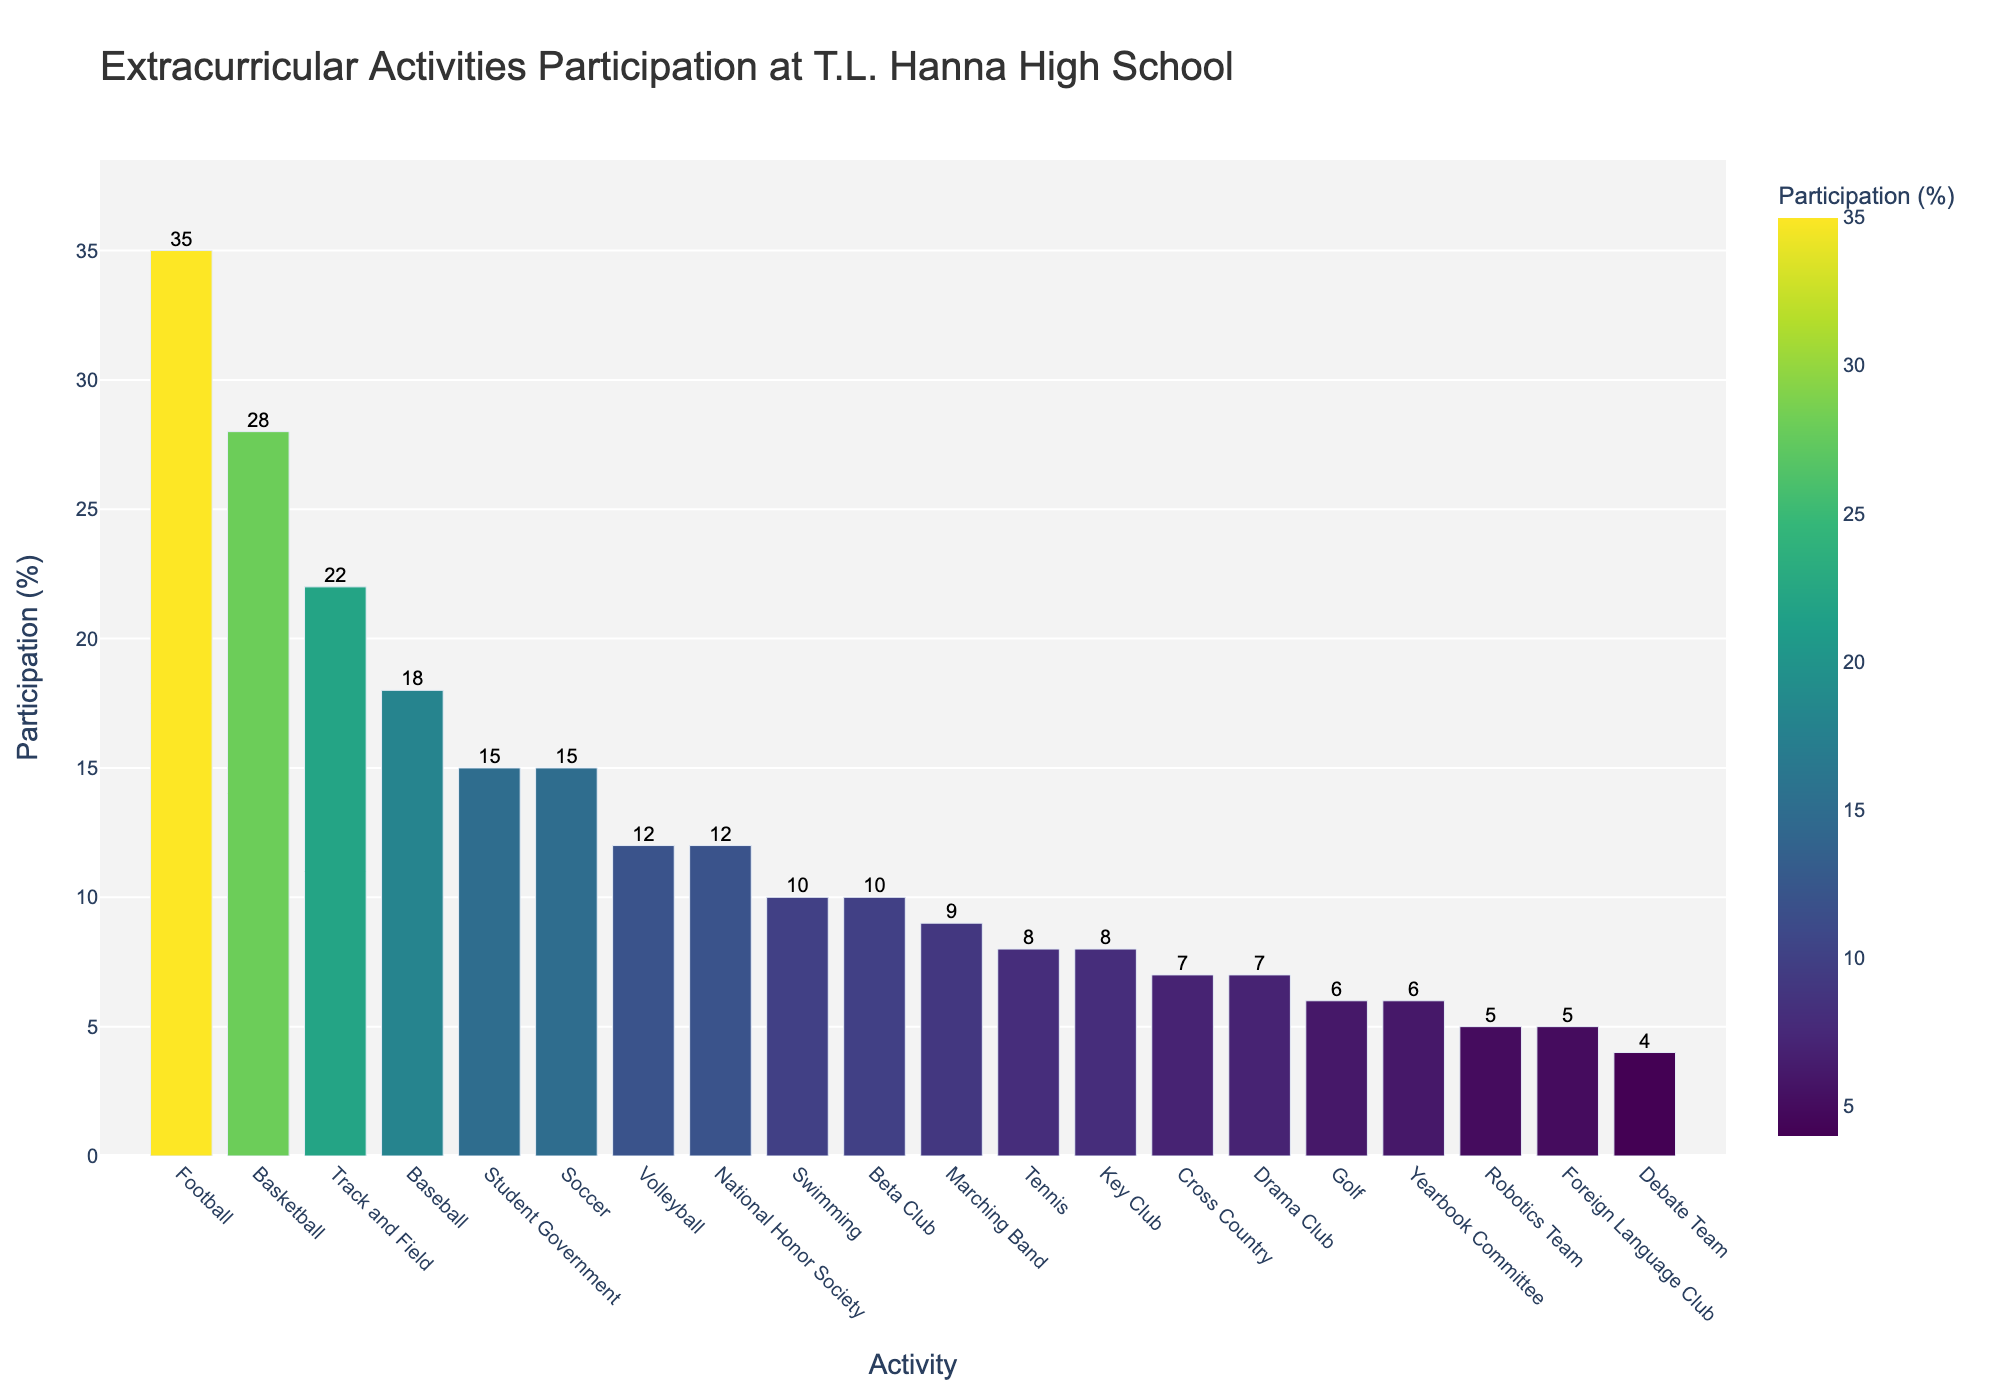Which activity has the highest participation percentage? The bar chart shows the participation percentages for each extracurricular activity. By observing the tallest bar, we see that Football has the highest participation percentage.
Answer: Football What is the difference in participation percentage between Football and Swimming? The bar chart shows that Football has a 35% participation rate, and Swimming has a 10% participation rate. The difference is calculated as 35% - 10%.
Answer: 25% Which two activities have equal participation percentages? By observing the heights of the bars, we see that both Soccer and Student Government have a participation rate of 15%.
Answer: Soccer and Student Government What is the combined participation percentage for Track and Field, and Volleyball? The participation percentages for Track and Field and Volleyball are 22% and 12%, respectively. Adding them together gives 22% + 12%.
Answer: 34% Which activity has the lowest participation percentage? The shortest bar in the bar chart represents the activity with the lowest participation percentage. We see that the Debate Team has the lowest participation at 4%.
Answer: Debate Team How many activities have a participation percentage greater than 20%? By observing the bars with percentages above 20%, we see three activities: Football (35%), Basketball (28%), and Track and Field (22%).
Answer: 3 What is the participation percentage for Marching Band, and how does it compare to Tennis? Marching Band has a participation percentage of 9%, and Tennis has 8%. Marching Band's participation is 1% higher than Tennis.
Answer: 9%, 1% higher What is the average participation percentage of the extracurricular activities? To find the average, sum up the participation percentages of all activities and divide by the number of activities. The sum is 264%, and there are 20 activities. So, the average is 264% ÷ 20.
Answer: 13.2% Which activity has a higher participation percentage: Beta Club or Yearbook Committee? Beta Club has a participation percentage of 10%, while Yearbook Committee has 6%. Beta Club has a higher participation percentage.
Answer: Beta Club What is the participation difference between the activities with the highest and lowest percentages? Football has the highest participation at 35%, and Debate Team has the lowest at 4%. The difference is calculated as 35% - 4%.
Answer: 31% 